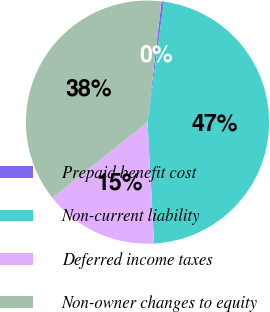Convert chart to OTSL. <chart><loc_0><loc_0><loc_500><loc_500><pie_chart><fcel>Prepaid benefit cost<fcel>Non-current liability<fcel>Deferred income taxes<fcel>Non-owner changes to equity<nl><fcel>0.32%<fcel>46.98%<fcel>15.18%<fcel>37.52%<nl></chart> 